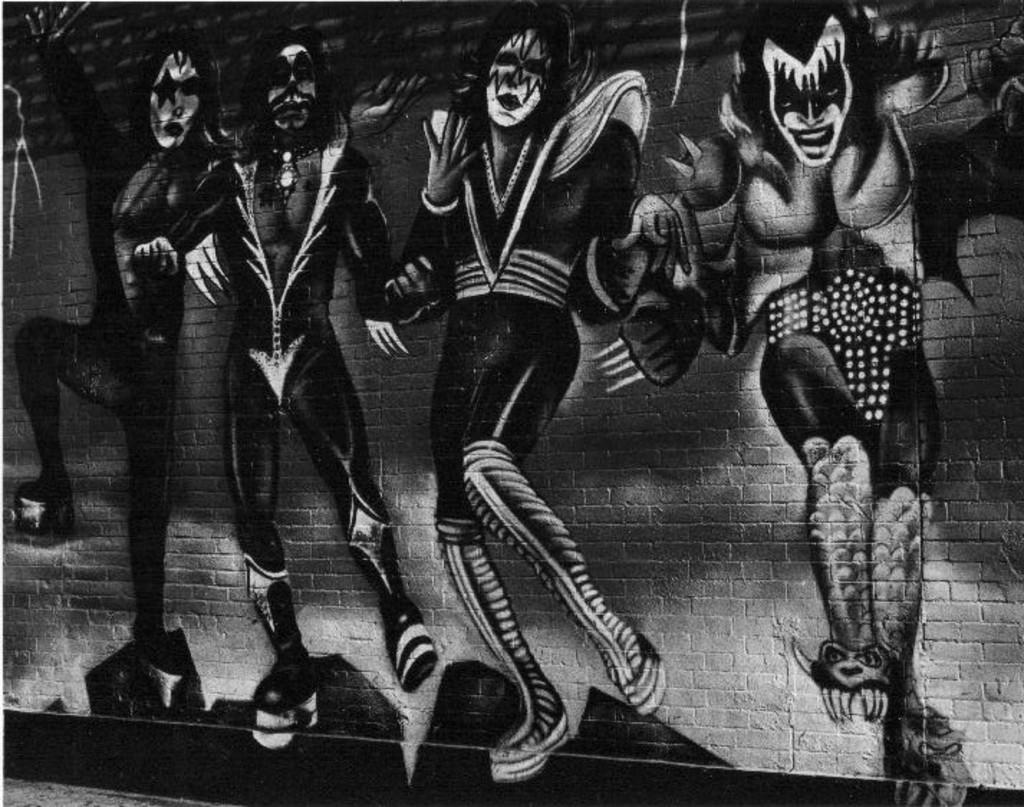What is present on the wall in the image? There is a painting on the wall in the image. What does the painting depict? The painting depicts several persons. Can you describe the wall in the image? The wall has a painting on it. What type of sign can be seen hanging from the plantation in the image? There is no sign or plantation present in the image; it only features a wall with a painting on it. 